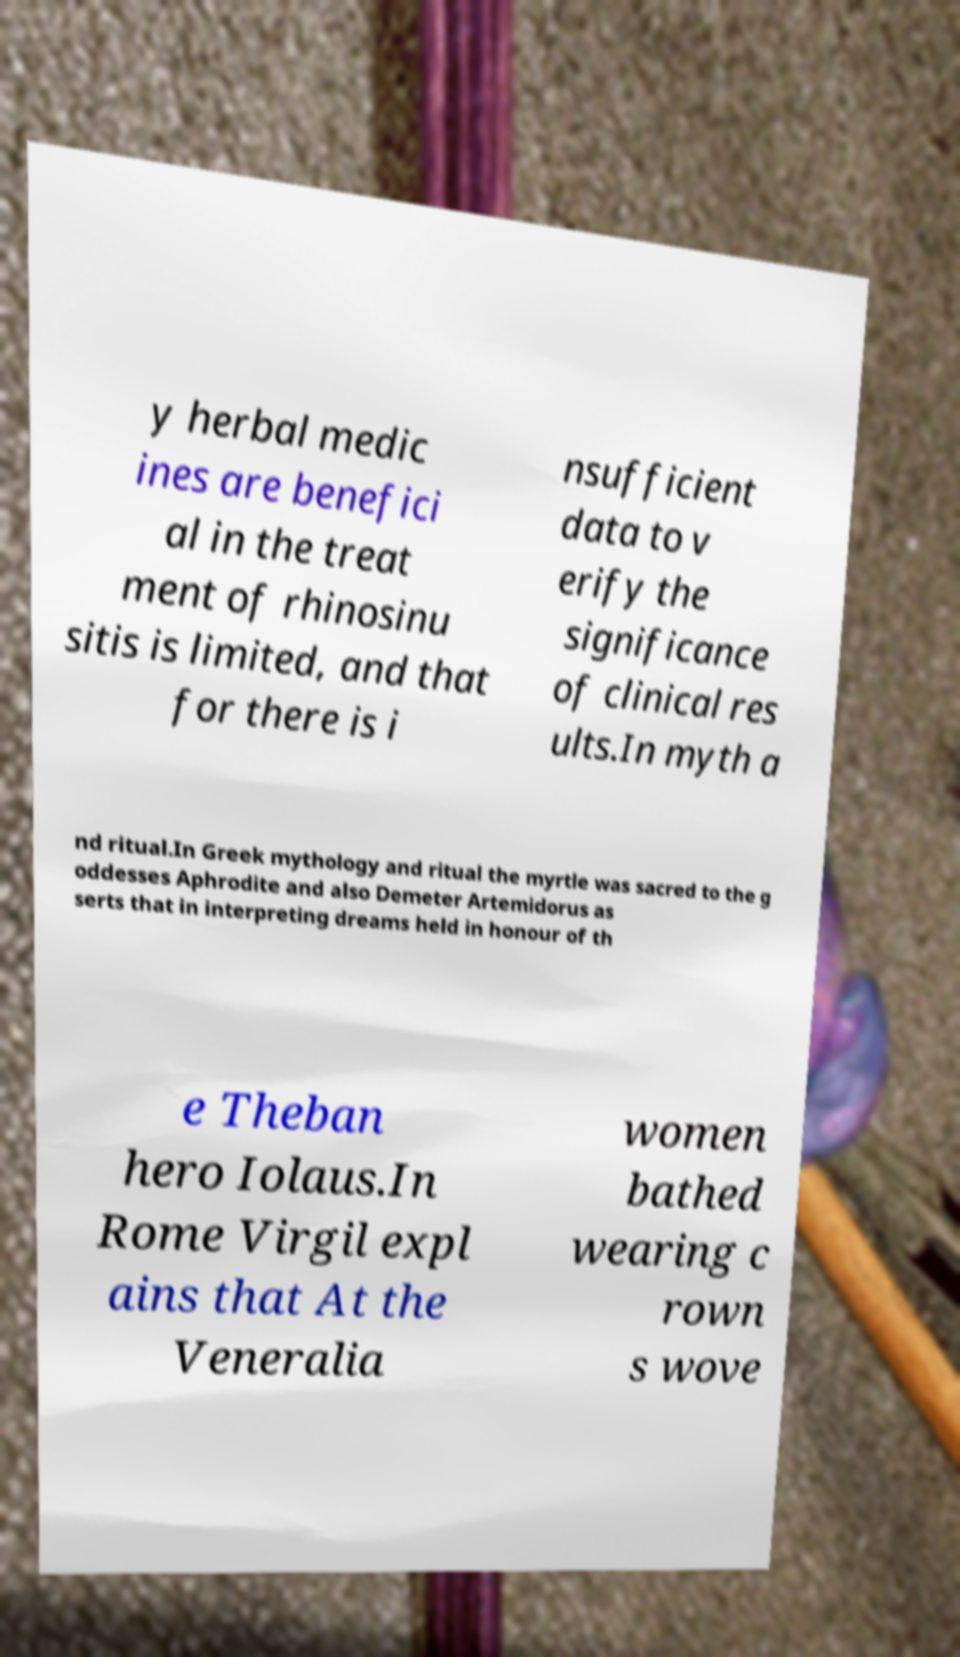I need the written content from this picture converted into text. Can you do that? y herbal medic ines are benefici al in the treat ment of rhinosinu sitis is limited, and that for there is i nsufficient data to v erify the significance of clinical res ults.In myth a nd ritual.In Greek mythology and ritual the myrtle was sacred to the g oddesses Aphrodite and also Demeter Artemidorus as serts that in interpreting dreams held in honour of th e Theban hero Iolaus.In Rome Virgil expl ains that At the Veneralia women bathed wearing c rown s wove 